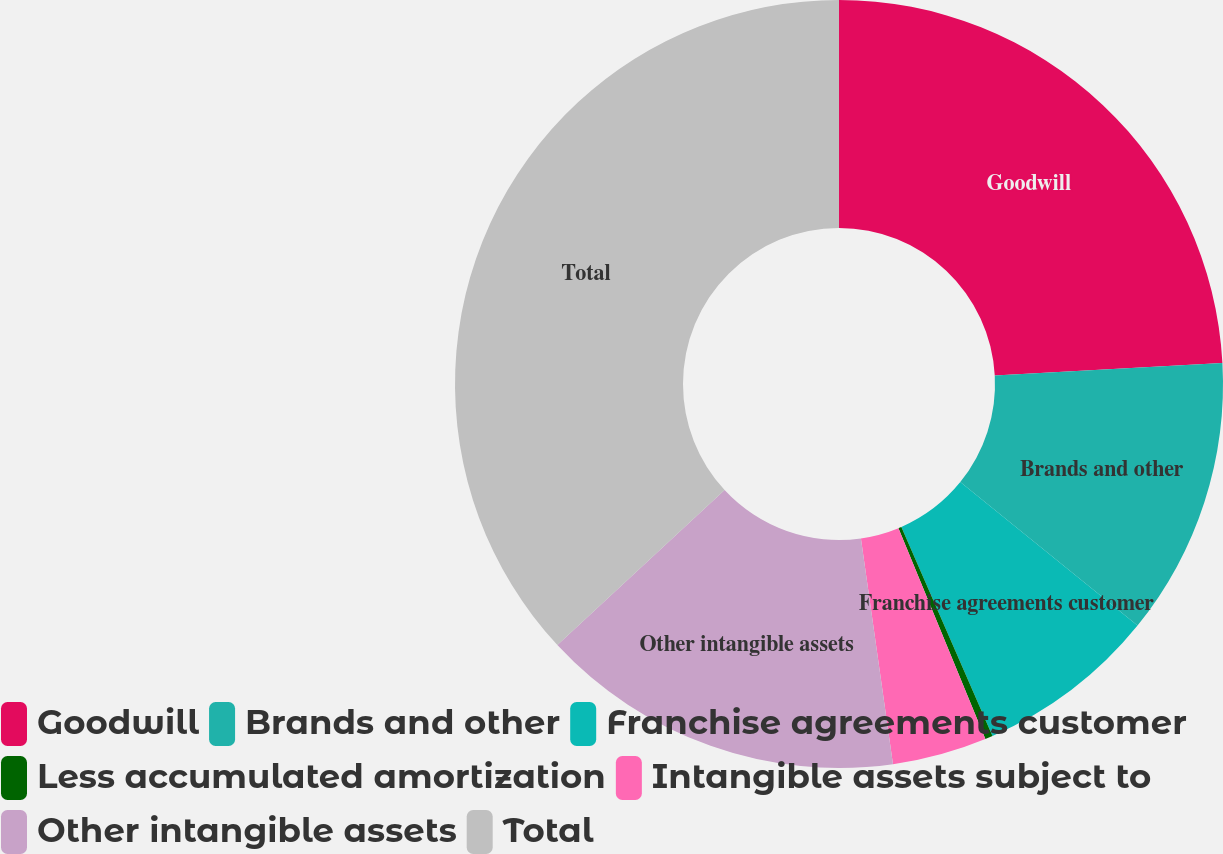Convert chart to OTSL. <chart><loc_0><loc_0><loc_500><loc_500><pie_chart><fcel>Goodwill<fcel>Brands and other<fcel>Franchise agreements customer<fcel>Less accumulated amortization<fcel>Intangible assets subject to<fcel>Other intangible assets<fcel>Total<nl><fcel>24.13%<fcel>11.7%<fcel>7.63%<fcel>0.32%<fcel>3.98%<fcel>15.35%<fcel>36.9%<nl></chart> 